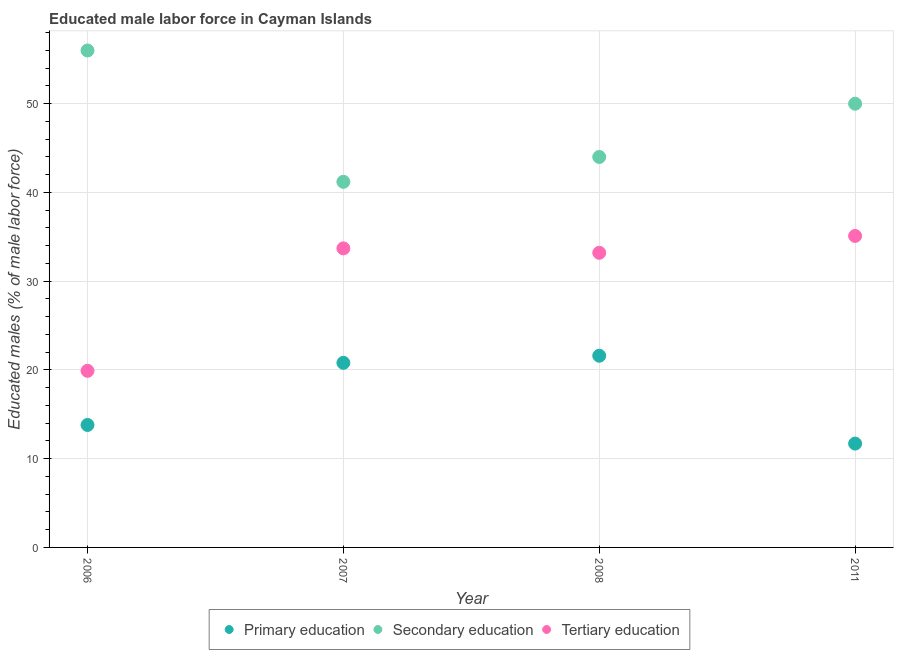How many different coloured dotlines are there?
Your answer should be very brief. 3. Is the number of dotlines equal to the number of legend labels?
Offer a terse response. Yes. What is the percentage of male labor force who received secondary education in 2006?
Give a very brief answer. 56. Across all years, what is the maximum percentage of male labor force who received tertiary education?
Make the answer very short. 35.1. Across all years, what is the minimum percentage of male labor force who received tertiary education?
Your answer should be very brief. 19.9. What is the total percentage of male labor force who received secondary education in the graph?
Offer a terse response. 191.2. What is the difference between the percentage of male labor force who received tertiary education in 2007 and that in 2011?
Provide a succinct answer. -1.4. What is the difference between the percentage of male labor force who received primary education in 2011 and the percentage of male labor force who received tertiary education in 2008?
Your answer should be very brief. -21.5. What is the average percentage of male labor force who received tertiary education per year?
Ensure brevity in your answer.  30.47. In the year 2006, what is the difference between the percentage of male labor force who received tertiary education and percentage of male labor force who received primary education?
Give a very brief answer. 6.1. What is the ratio of the percentage of male labor force who received tertiary education in 2007 to that in 2011?
Ensure brevity in your answer.  0.96. Is the percentage of male labor force who received secondary education in 2006 less than that in 2007?
Your response must be concise. No. Is the difference between the percentage of male labor force who received tertiary education in 2007 and 2008 greater than the difference between the percentage of male labor force who received secondary education in 2007 and 2008?
Keep it short and to the point. Yes. What is the difference between the highest and the second highest percentage of male labor force who received tertiary education?
Provide a succinct answer. 1.4. What is the difference between the highest and the lowest percentage of male labor force who received tertiary education?
Make the answer very short. 15.2. In how many years, is the percentage of male labor force who received tertiary education greater than the average percentage of male labor force who received tertiary education taken over all years?
Keep it short and to the point. 3. Does the graph contain any zero values?
Your answer should be compact. No. Does the graph contain grids?
Keep it short and to the point. Yes. Where does the legend appear in the graph?
Provide a short and direct response. Bottom center. How many legend labels are there?
Keep it short and to the point. 3. How are the legend labels stacked?
Offer a terse response. Horizontal. What is the title of the graph?
Offer a very short reply. Educated male labor force in Cayman Islands. What is the label or title of the X-axis?
Offer a terse response. Year. What is the label or title of the Y-axis?
Ensure brevity in your answer.  Educated males (% of male labor force). What is the Educated males (% of male labor force) in Primary education in 2006?
Ensure brevity in your answer.  13.8. What is the Educated males (% of male labor force) in Secondary education in 2006?
Offer a terse response. 56. What is the Educated males (% of male labor force) of Tertiary education in 2006?
Keep it short and to the point. 19.9. What is the Educated males (% of male labor force) of Primary education in 2007?
Offer a terse response. 20.8. What is the Educated males (% of male labor force) in Secondary education in 2007?
Provide a succinct answer. 41.2. What is the Educated males (% of male labor force) of Tertiary education in 2007?
Your answer should be very brief. 33.7. What is the Educated males (% of male labor force) of Primary education in 2008?
Offer a very short reply. 21.6. What is the Educated males (% of male labor force) in Secondary education in 2008?
Give a very brief answer. 44. What is the Educated males (% of male labor force) in Tertiary education in 2008?
Offer a very short reply. 33.2. What is the Educated males (% of male labor force) in Primary education in 2011?
Make the answer very short. 11.7. What is the Educated males (% of male labor force) of Secondary education in 2011?
Offer a very short reply. 50. What is the Educated males (% of male labor force) in Tertiary education in 2011?
Provide a short and direct response. 35.1. Across all years, what is the maximum Educated males (% of male labor force) of Primary education?
Provide a succinct answer. 21.6. Across all years, what is the maximum Educated males (% of male labor force) in Tertiary education?
Keep it short and to the point. 35.1. Across all years, what is the minimum Educated males (% of male labor force) of Primary education?
Keep it short and to the point. 11.7. Across all years, what is the minimum Educated males (% of male labor force) in Secondary education?
Your response must be concise. 41.2. Across all years, what is the minimum Educated males (% of male labor force) of Tertiary education?
Provide a succinct answer. 19.9. What is the total Educated males (% of male labor force) in Primary education in the graph?
Make the answer very short. 67.9. What is the total Educated males (% of male labor force) of Secondary education in the graph?
Keep it short and to the point. 191.2. What is the total Educated males (% of male labor force) of Tertiary education in the graph?
Make the answer very short. 121.9. What is the difference between the Educated males (% of male labor force) of Secondary education in 2006 and that in 2007?
Offer a very short reply. 14.8. What is the difference between the Educated males (% of male labor force) of Tertiary education in 2006 and that in 2007?
Provide a succinct answer. -13.8. What is the difference between the Educated males (% of male labor force) of Secondary education in 2006 and that in 2008?
Provide a short and direct response. 12. What is the difference between the Educated males (% of male labor force) of Tertiary education in 2006 and that in 2008?
Offer a very short reply. -13.3. What is the difference between the Educated males (% of male labor force) in Secondary education in 2006 and that in 2011?
Your answer should be compact. 6. What is the difference between the Educated males (% of male labor force) of Tertiary education in 2006 and that in 2011?
Make the answer very short. -15.2. What is the difference between the Educated males (% of male labor force) in Secondary education in 2007 and that in 2008?
Your answer should be very brief. -2.8. What is the difference between the Educated males (% of male labor force) in Tertiary education in 2007 and that in 2008?
Provide a short and direct response. 0.5. What is the difference between the Educated males (% of male labor force) in Primary education in 2007 and that in 2011?
Ensure brevity in your answer.  9.1. What is the difference between the Educated males (% of male labor force) of Secondary education in 2007 and that in 2011?
Offer a very short reply. -8.8. What is the difference between the Educated males (% of male labor force) of Tertiary education in 2007 and that in 2011?
Keep it short and to the point. -1.4. What is the difference between the Educated males (% of male labor force) of Primary education in 2008 and that in 2011?
Keep it short and to the point. 9.9. What is the difference between the Educated males (% of male labor force) of Primary education in 2006 and the Educated males (% of male labor force) of Secondary education in 2007?
Your answer should be compact. -27.4. What is the difference between the Educated males (% of male labor force) in Primary education in 2006 and the Educated males (% of male labor force) in Tertiary education in 2007?
Provide a succinct answer. -19.9. What is the difference between the Educated males (% of male labor force) of Secondary education in 2006 and the Educated males (% of male labor force) of Tertiary education in 2007?
Keep it short and to the point. 22.3. What is the difference between the Educated males (% of male labor force) of Primary education in 2006 and the Educated males (% of male labor force) of Secondary education in 2008?
Offer a terse response. -30.2. What is the difference between the Educated males (% of male labor force) of Primary education in 2006 and the Educated males (% of male labor force) of Tertiary education in 2008?
Offer a very short reply. -19.4. What is the difference between the Educated males (% of male labor force) of Secondary education in 2006 and the Educated males (% of male labor force) of Tertiary education in 2008?
Your answer should be very brief. 22.8. What is the difference between the Educated males (% of male labor force) of Primary education in 2006 and the Educated males (% of male labor force) of Secondary education in 2011?
Your answer should be compact. -36.2. What is the difference between the Educated males (% of male labor force) of Primary education in 2006 and the Educated males (% of male labor force) of Tertiary education in 2011?
Offer a very short reply. -21.3. What is the difference between the Educated males (% of male labor force) in Secondary education in 2006 and the Educated males (% of male labor force) in Tertiary education in 2011?
Provide a succinct answer. 20.9. What is the difference between the Educated males (% of male labor force) in Primary education in 2007 and the Educated males (% of male labor force) in Secondary education in 2008?
Your answer should be compact. -23.2. What is the difference between the Educated males (% of male labor force) in Primary education in 2007 and the Educated males (% of male labor force) in Tertiary education in 2008?
Provide a succinct answer. -12.4. What is the difference between the Educated males (% of male labor force) of Secondary education in 2007 and the Educated males (% of male labor force) of Tertiary education in 2008?
Offer a very short reply. 8. What is the difference between the Educated males (% of male labor force) in Primary education in 2007 and the Educated males (% of male labor force) in Secondary education in 2011?
Give a very brief answer. -29.2. What is the difference between the Educated males (% of male labor force) of Primary education in 2007 and the Educated males (% of male labor force) of Tertiary education in 2011?
Offer a very short reply. -14.3. What is the difference between the Educated males (% of male labor force) of Secondary education in 2007 and the Educated males (% of male labor force) of Tertiary education in 2011?
Offer a very short reply. 6.1. What is the difference between the Educated males (% of male labor force) of Primary education in 2008 and the Educated males (% of male labor force) of Secondary education in 2011?
Make the answer very short. -28.4. What is the average Educated males (% of male labor force) of Primary education per year?
Provide a succinct answer. 16.98. What is the average Educated males (% of male labor force) in Secondary education per year?
Make the answer very short. 47.8. What is the average Educated males (% of male labor force) in Tertiary education per year?
Provide a short and direct response. 30.48. In the year 2006, what is the difference between the Educated males (% of male labor force) of Primary education and Educated males (% of male labor force) of Secondary education?
Provide a succinct answer. -42.2. In the year 2006, what is the difference between the Educated males (% of male labor force) in Secondary education and Educated males (% of male labor force) in Tertiary education?
Offer a terse response. 36.1. In the year 2007, what is the difference between the Educated males (% of male labor force) in Primary education and Educated males (% of male labor force) in Secondary education?
Provide a succinct answer. -20.4. In the year 2008, what is the difference between the Educated males (% of male labor force) in Primary education and Educated males (% of male labor force) in Secondary education?
Provide a succinct answer. -22.4. In the year 2008, what is the difference between the Educated males (% of male labor force) of Primary education and Educated males (% of male labor force) of Tertiary education?
Give a very brief answer. -11.6. In the year 2011, what is the difference between the Educated males (% of male labor force) in Primary education and Educated males (% of male labor force) in Secondary education?
Make the answer very short. -38.3. In the year 2011, what is the difference between the Educated males (% of male labor force) of Primary education and Educated males (% of male labor force) of Tertiary education?
Make the answer very short. -23.4. What is the ratio of the Educated males (% of male labor force) of Primary education in 2006 to that in 2007?
Give a very brief answer. 0.66. What is the ratio of the Educated males (% of male labor force) in Secondary education in 2006 to that in 2007?
Ensure brevity in your answer.  1.36. What is the ratio of the Educated males (% of male labor force) in Tertiary education in 2006 to that in 2007?
Your answer should be very brief. 0.59. What is the ratio of the Educated males (% of male labor force) of Primary education in 2006 to that in 2008?
Your answer should be very brief. 0.64. What is the ratio of the Educated males (% of male labor force) of Secondary education in 2006 to that in 2008?
Your answer should be very brief. 1.27. What is the ratio of the Educated males (% of male labor force) of Tertiary education in 2006 to that in 2008?
Give a very brief answer. 0.6. What is the ratio of the Educated males (% of male labor force) of Primary education in 2006 to that in 2011?
Your answer should be compact. 1.18. What is the ratio of the Educated males (% of male labor force) of Secondary education in 2006 to that in 2011?
Provide a succinct answer. 1.12. What is the ratio of the Educated males (% of male labor force) of Tertiary education in 2006 to that in 2011?
Provide a succinct answer. 0.57. What is the ratio of the Educated males (% of male labor force) in Secondary education in 2007 to that in 2008?
Provide a short and direct response. 0.94. What is the ratio of the Educated males (% of male labor force) of Tertiary education in 2007 to that in 2008?
Offer a terse response. 1.02. What is the ratio of the Educated males (% of male labor force) in Primary education in 2007 to that in 2011?
Your answer should be very brief. 1.78. What is the ratio of the Educated males (% of male labor force) of Secondary education in 2007 to that in 2011?
Your response must be concise. 0.82. What is the ratio of the Educated males (% of male labor force) in Tertiary education in 2007 to that in 2011?
Ensure brevity in your answer.  0.96. What is the ratio of the Educated males (% of male labor force) of Primary education in 2008 to that in 2011?
Your response must be concise. 1.85. What is the ratio of the Educated males (% of male labor force) in Tertiary education in 2008 to that in 2011?
Keep it short and to the point. 0.95. What is the difference between the highest and the second highest Educated males (% of male labor force) in Primary education?
Keep it short and to the point. 0.8. What is the difference between the highest and the lowest Educated males (% of male labor force) of Primary education?
Your answer should be very brief. 9.9. 